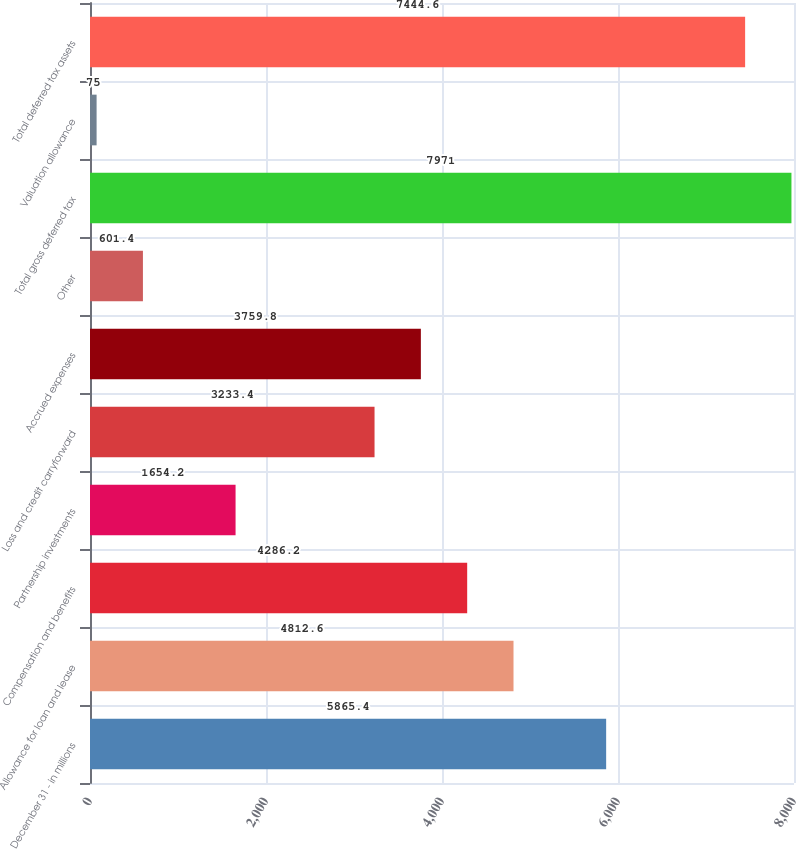<chart> <loc_0><loc_0><loc_500><loc_500><bar_chart><fcel>December 31 - in millions<fcel>Allowance for loan and lease<fcel>Compensation and benefits<fcel>Partnership investments<fcel>Loss and credit carryforward<fcel>Accrued expenses<fcel>Other<fcel>Total gross deferred tax<fcel>Valuation allowance<fcel>Total deferred tax assets<nl><fcel>5865.4<fcel>4812.6<fcel>4286.2<fcel>1654.2<fcel>3233.4<fcel>3759.8<fcel>601.4<fcel>7971<fcel>75<fcel>7444.6<nl></chart> 